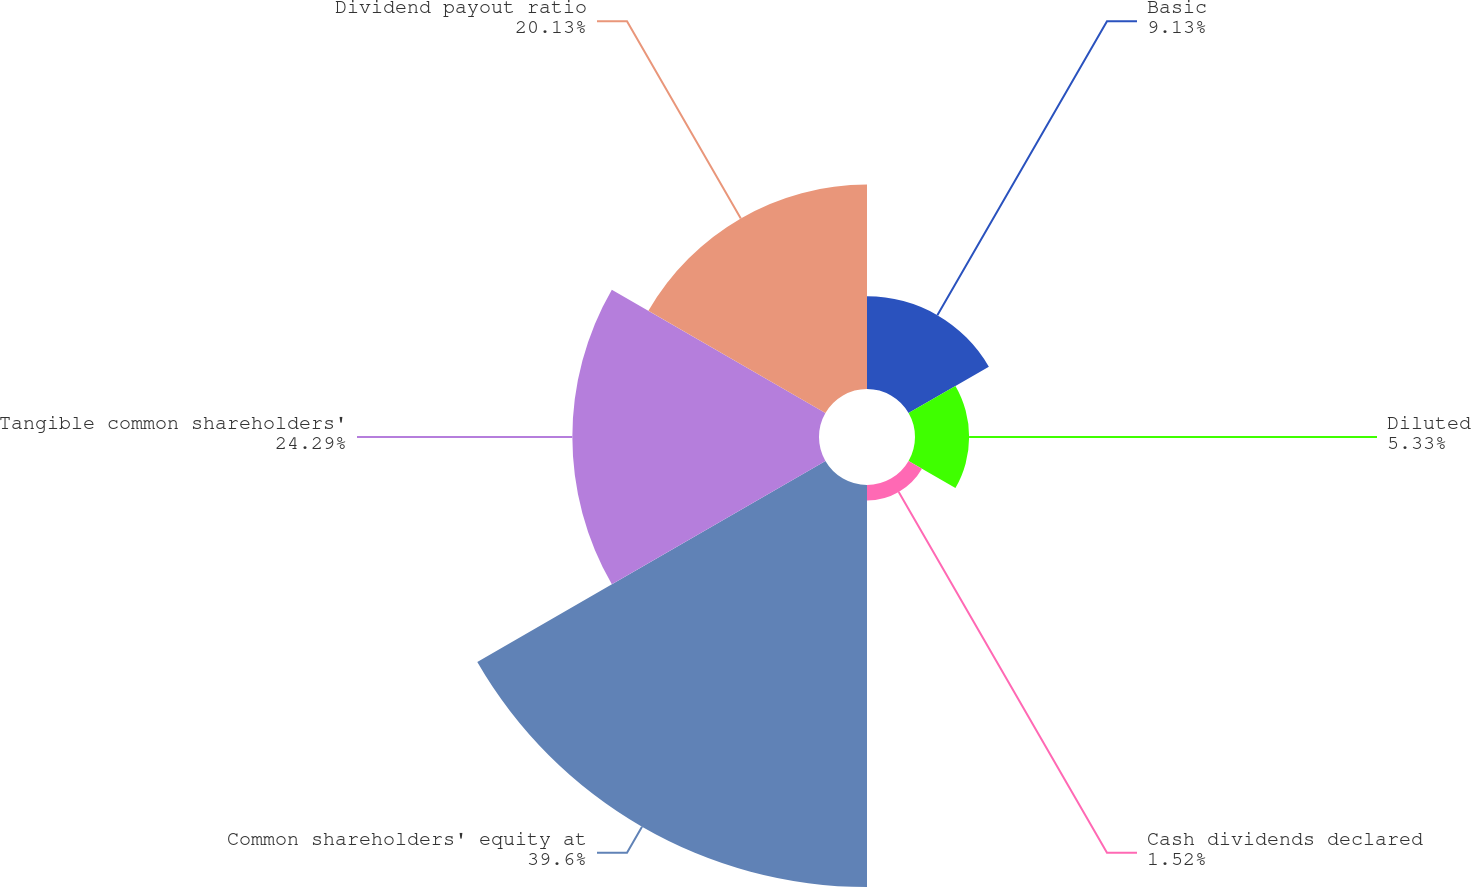Convert chart to OTSL. <chart><loc_0><loc_0><loc_500><loc_500><pie_chart><fcel>Basic<fcel>Diluted<fcel>Cash dividends declared<fcel>Common shareholders' equity at<fcel>Tangible common shareholders'<fcel>Dividend payout ratio<nl><fcel>9.13%<fcel>5.33%<fcel>1.52%<fcel>39.59%<fcel>24.29%<fcel>20.13%<nl></chart> 